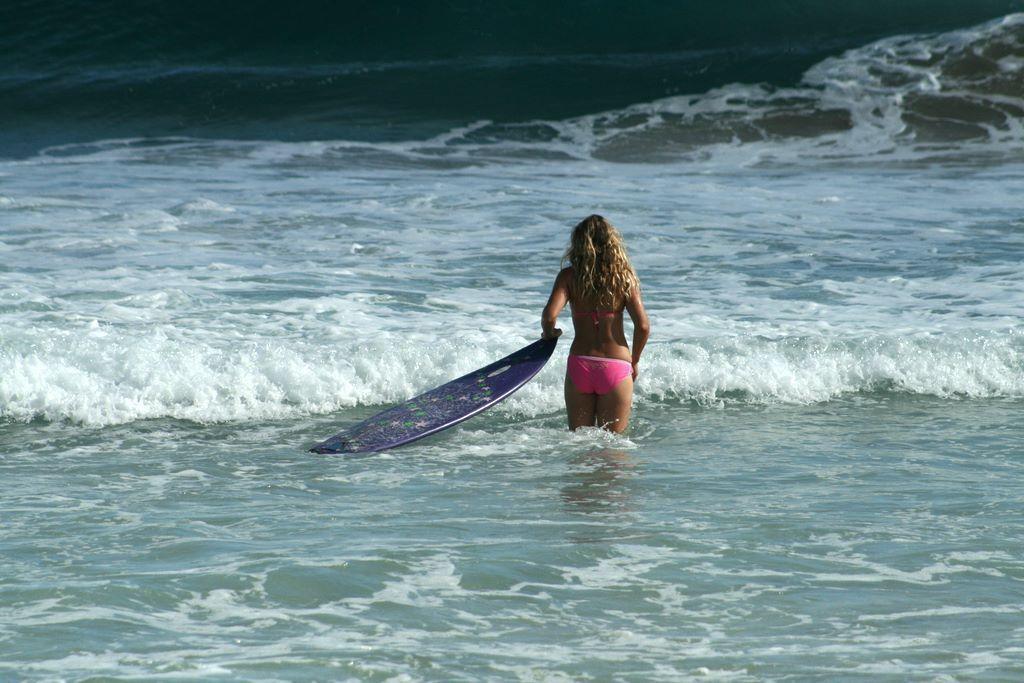Describe this image in one or two sentences. In this picture a woman is holding a surfboard and she is in the water. 